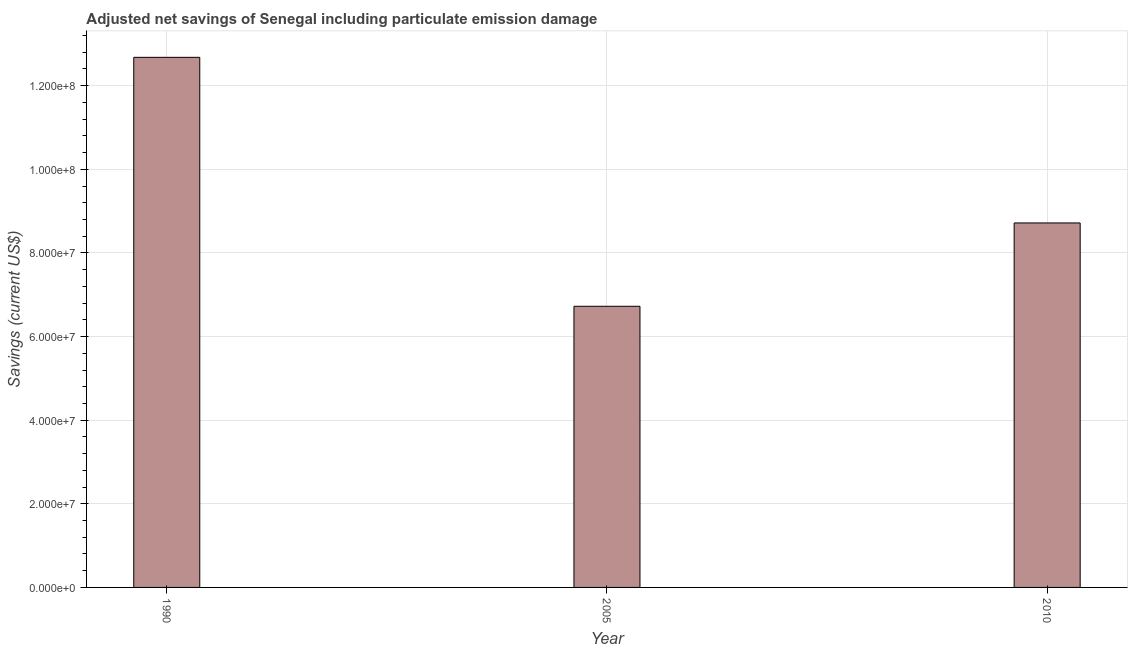What is the title of the graph?
Your answer should be very brief. Adjusted net savings of Senegal including particulate emission damage. What is the label or title of the Y-axis?
Make the answer very short. Savings (current US$). What is the adjusted net savings in 2010?
Your answer should be compact. 8.72e+07. Across all years, what is the maximum adjusted net savings?
Offer a very short reply. 1.27e+08. Across all years, what is the minimum adjusted net savings?
Provide a succinct answer. 6.72e+07. In which year was the adjusted net savings maximum?
Provide a short and direct response. 1990. What is the sum of the adjusted net savings?
Provide a short and direct response. 2.81e+08. What is the difference between the adjusted net savings in 2005 and 2010?
Make the answer very short. -1.99e+07. What is the average adjusted net savings per year?
Your answer should be very brief. 9.37e+07. What is the median adjusted net savings?
Provide a succinct answer. 8.72e+07. What is the ratio of the adjusted net savings in 2005 to that in 2010?
Your answer should be compact. 0.77. Is the adjusted net savings in 1990 less than that in 2005?
Provide a succinct answer. No. What is the difference between the highest and the second highest adjusted net savings?
Keep it short and to the point. 3.96e+07. What is the difference between the highest and the lowest adjusted net savings?
Offer a terse response. 5.95e+07. Are all the bars in the graph horizontal?
Keep it short and to the point. No. What is the Savings (current US$) in 1990?
Offer a terse response. 1.27e+08. What is the Savings (current US$) in 2005?
Make the answer very short. 6.72e+07. What is the Savings (current US$) in 2010?
Offer a terse response. 8.72e+07. What is the difference between the Savings (current US$) in 1990 and 2005?
Your answer should be compact. 5.95e+07. What is the difference between the Savings (current US$) in 1990 and 2010?
Your answer should be compact. 3.96e+07. What is the difference between the Savings (current US$) in 2005 and 2010?
Your answer should be very brief. -1.99e+07. What is the ratio of the Savings (current US$) in 1990 to that in 2005?
Give a very brief answer. 1.89. What is the ratio of the Savings (current US$) in 1990 to that in 2010?
Offer a very short reply. 1.45. What is the ratio of the Savings (current US$) in 2005 to that in 2010?
Ensure brevity in your answer.  0.77. 